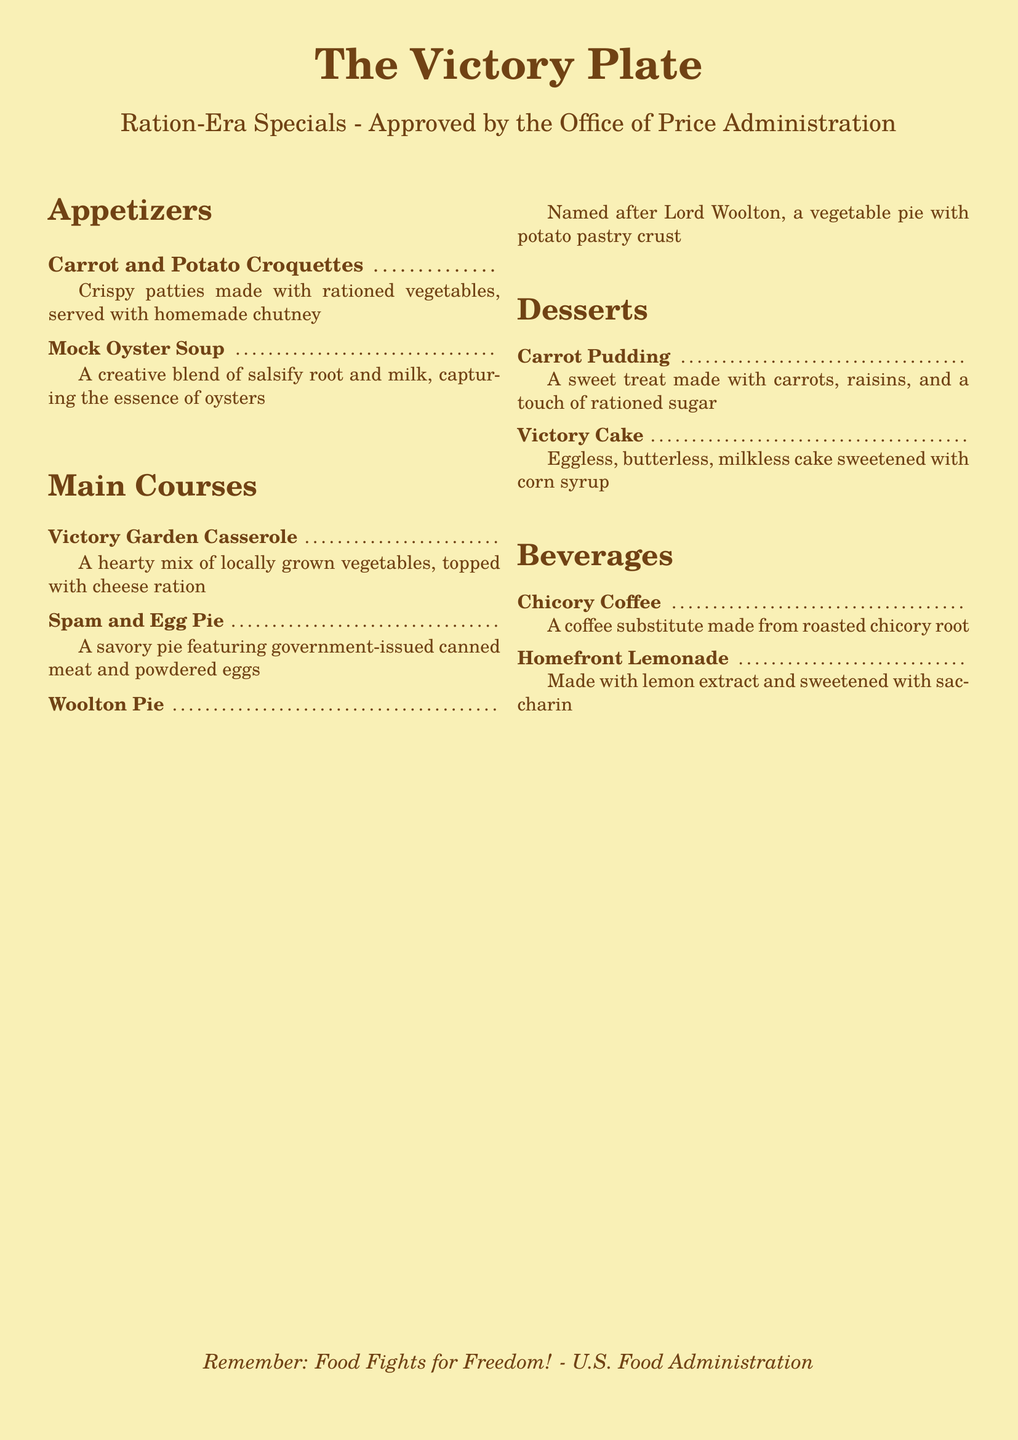What is the name of the restaurant? The restaurant is titled "The Victory Plate."
Answer: The Victory Plate How many appetizers are listed on the menu? There are two appetizers mentioned in the document.
Answer: 2 What is used as a coffee substitute? Chicory root is used as a coffee substitute.
Answer: Chicory root What type of pie is featured in the main courses? One of the pies listed is the "Spam and Egg Pie."
Answer: Spam and Egg Pie Which dessert is eggless? The dessert "Victory Cake" is explicitly mentioned as eggless.
Answer: Victory Cake What is the main ingredient in Mock Oyster Soup? The main ingredient in Mock Oyster Soup is salsify root.
Answer: Salsify root What topping is used on the Victory Garden Casserole? The casserole is topped with cheese ration.
Answer: Cheese ration What is used to sweeten the Homefront Lemonade? Homefront Lemonade is sweetened with saccharin.
Answer: Saccharin 